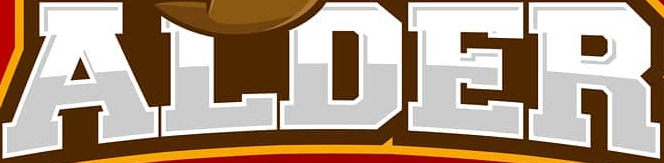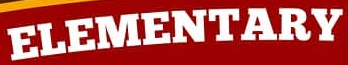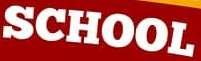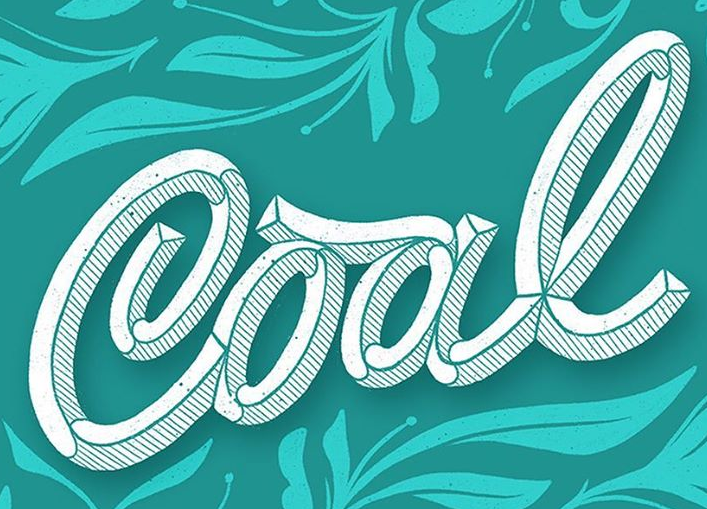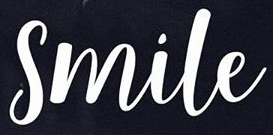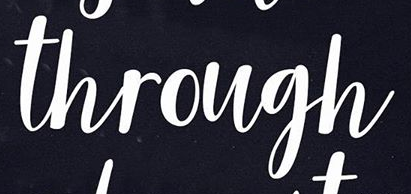What words are shown in these images in order, separated by a semicolon? ALDER; ELEMENTARY; SCHOOL; Cool; Smile; through 